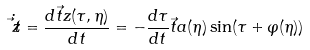Convert formula to latex. <formula><loc_0><loc_0><loc_500><loc_500>\dot { \vec { t } { z } } = \frac { d { \vec { t } { z } } ( \tau , \eta ) } { d t } = - \frac { d \tau } { d t } { \vec { t } { a } } ( \eta ) \sin ( \tau + \varphi ( \eta ) )</formula> 